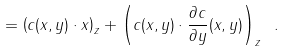Convert formula to latex. <formula><loc_0><loc_0><loc_500><loc_500>= \left ( c ( x , y ) \cdot x \right ) _ { z } + \left ( c ( x , y ) \cdot \frac { \partial c } { \partial y } ( x , y ) \right ) _ { z } \ .</formula> 